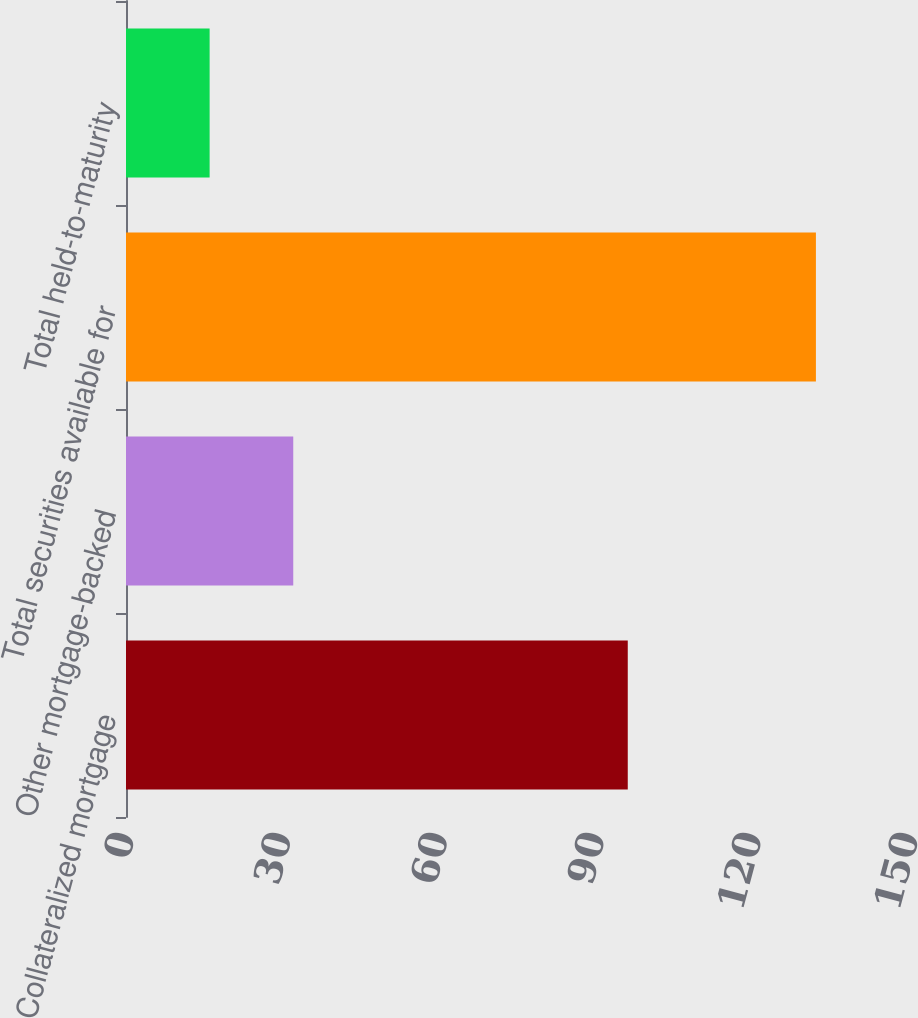Convert chart to OTSL. <chart><loc_0><loc_0><loc_500><loc_500><bar_chart><fcel>Collateralized mortgage<fcel>Other mortgage-backed<fcel>Total securities available for<fcel>Total held-to-maturity<nl><fcel>96<fcel>32<fcel>132<fcel>16<nl></chart> 